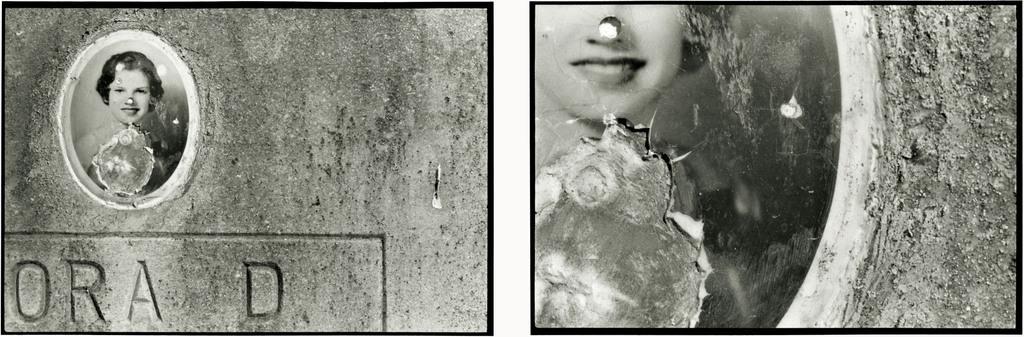Please provide a concise description of this image. In this image I can see two collage photos of a girl. On the bottom left side I can see something is written and I can see color of this image is black and white. 